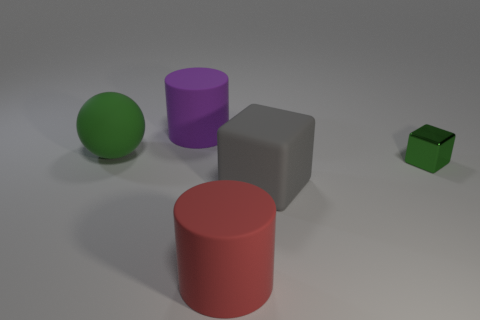Does the object behind the large ball have the same material as the tiny object?
Offer a terse response. No. What number of small objects are there?
Your response must be concise. 1. How many objects are either gray matte blocks or small blue rubber blocks?
Provide a short and direct response. 1. There is a rubber cube to the right of the green thing that is behind the green metallic cube; how many objects are right of it?
Ensure brevity in your answer.  1. Are there any other things that are the same color as the big matte ball?
Provide a succinct answer. Yes. Do the rubber object that is right of the red matte cylinder and the big object left of the large purple rubber cylinder have the same color?
Make the answer very short. No. Is the number of tiny green cubes behind the tiny metal object greater than the number of purple rubber cylinders that are right of the big rubber block?
Make the answer very short. No. What is the material of the large red thing?
Give a very brief answer. Rubber. The big thing that is on the left side of the big matte cylinder behind the metallic cube to the right of the large cube is what shape?
Provide a succinct answer. Sphere. What number of other things are there of the same material as the red thing
Provide a short and direct response. 3. 